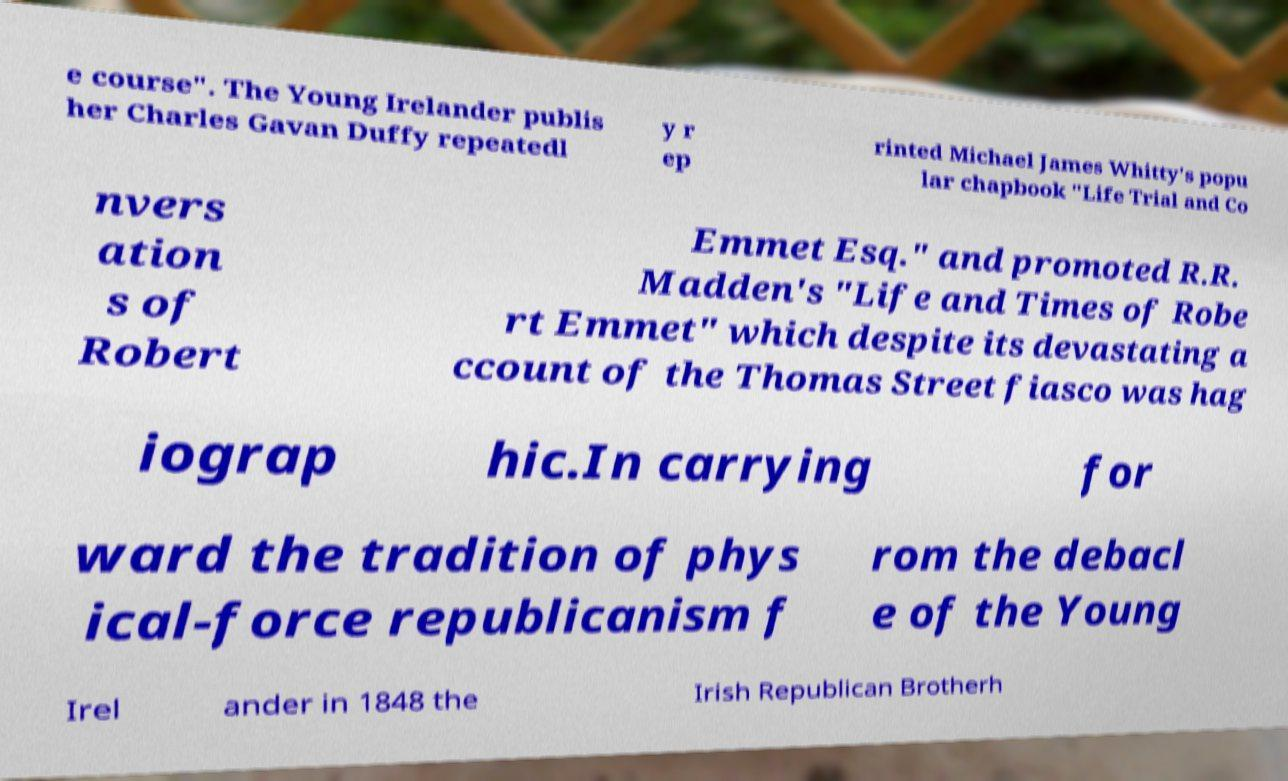Please read and relay the text visible in this image. What does it say? e course". The Young Irelander publis her Charles Gavan Duffy repeatedl y r ep rinted Michael James Whitty's popu lar chapbook "Life Trial and Co nvers ation s of Robert Emmet Esq." and promoted R.R. Madden's "Life and Times of Robe rt Emmet" which despite its devastating a ccount of the Thomas Street fiasco was hag iograp hic.In carrying for ward the tradition of phys ical-force republicanism f rom the debacl e of the Young Irel ander in 1848 the Irish Republican Brotherh 